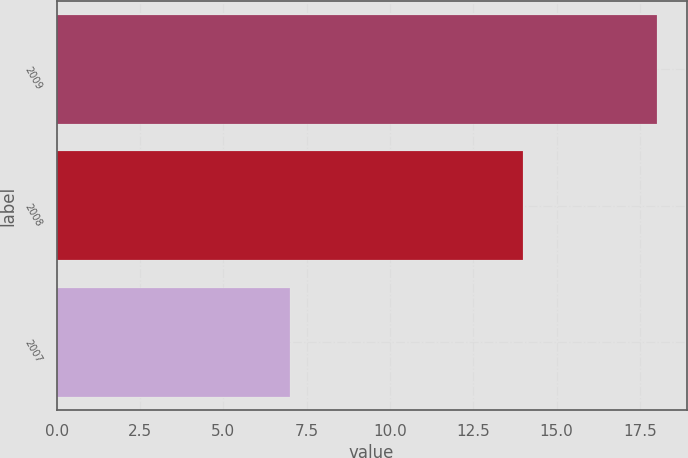Convert chart to OTSL. <chart><loc_0><loc_0><loc_500><loc_500><bar_chart><fcel>2009<fcel>2008<fcel>2007<nl><fcel>18<fcel>14<fcel>7<nl></chart> 